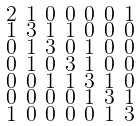<formula> <loc_0><loc_0><loc_500><loc_500>\begin{smallmatrix} 2 & 1 & 0 & 0 & 0 & 0 & 1 \\ 1 & 3 & 1 & 1 & 0 & 0 & 0 \\ 0 & 1 & 3 & 0 & 1 & 0 & 0 \\ 0 & 1 & 0 & 3 & 1 & 0 & 0 \\ 0 & 0 & 1 & 1 & 3 & 1 & 0 \\ 0 & 0 & 0 & 0 & 1 & 3 & 1 \\ 1 & 0 & 0 & 0 & 0 & 1 & 3 \end{smallmatrix}</formula> 